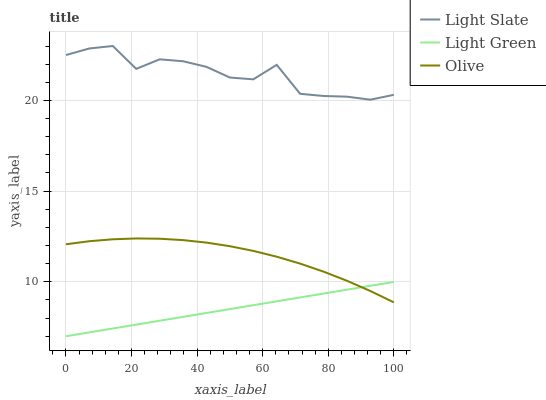Does Light Green have the minimum area under the curve?
Answer yes or no. Yes. Does Light Slate have the maximum area under the curve?
Answer yes or no. Yes. Does Olive have the minimum area under the curve?
Answer yes or no. No. Does Olive have the maximum area under the curve?
Answer yes or no. No. Is Light Green the smoothest?
Answer yes or no. Yes. Is Light Slate the roughest?
Answer yes or no. Yes. Is Olive the smoothest?
Answer yes or no. No. Is Olive the roughest?
Answer yes or no. No. Does Light Green have the lowest value?
Answer yes or no. Yes. Does Olive have the lowest value?
Answer yes or no. No. Does Light Slate have the highest value?
Answer yes or no. Yes. Does Olive have the highest value?
Answer yes or no. No. Is Light Green less than Light Slate?
Answer yes or no. Yes. Is Light Slate greater than Light Green?
Answer yes or no. Yes. Does Olive intersect Light Green?
Answer yes or no. Yes. Is Olive less than Light Green?
Answer yes or no. No. Is Olive greater than Light Green?
Answer yes or no. No. Does Light Green intersect Light Slate?
Answer yes or no. No. 